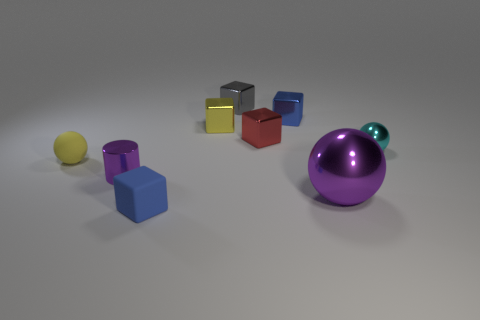Subtract all green balls. How many blue cubes are left? 2 Subtract all gray cubes. How many cubes are left? 4 Subtract all red blocks. How many blocks are left? 4 Subtract 2 blocks. How many blocks are left? 3 Subtract all brown blocks. Subtract all green cylinders. How many blocks are left? 5 Subtract all cylinders. How many objects are left? 8 Subtract 0 brown spheres. How many objects are left? 9 Subtract all tiny cyan metal objects. Subtract all yellow balls. How many objects are left? 7 Add 8 tiny cyan shiny objects. How many tiny cyan shiny objects are left? 9 Add 1 tiny metallic blocks. How many tiny metallic blocks exist? 5 